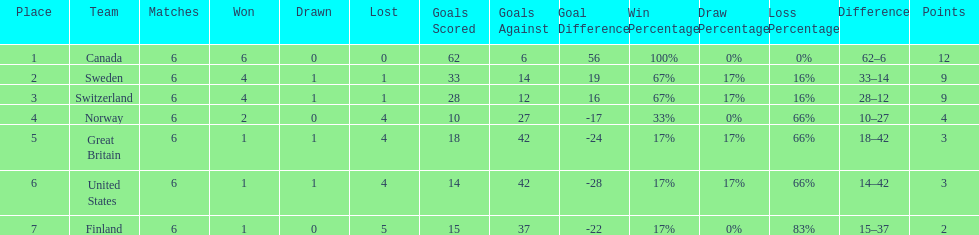How many teams won only 1 match? 3. 